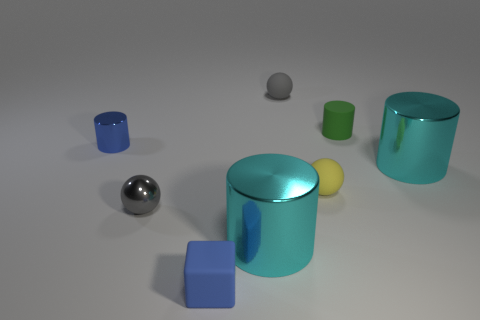Subtract all green cylinders. How many cylinders are left? 3 Subtract all yellow balls. How many balls are left? 2 Add 1 rubber balls. How many objects exist? 9 Subtract 2 spheres. How many spheres are left? 1 Subtract all cubes. How many objects are left? 7 Subtract all cyan blocks. How many gray spheres are left? 2 Subtract all tiny green things. Subtract all tiny gray rubber spheres. How many objects are left? 6 Add 4 small shiny things. How many small shiny things are left? 6 Add 1 large cyan metallic cylinders. How many large cyan metallic cylinders exist? 3 Subtract 0 gray blocks. How many objects are left? 8 